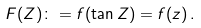Convert formula to latex. <formula><loc_0><loc_0><loc_500><loc_500>F ( Z ) \colon = f ( \tan Z ) = f ( z ) \, .</formula> 